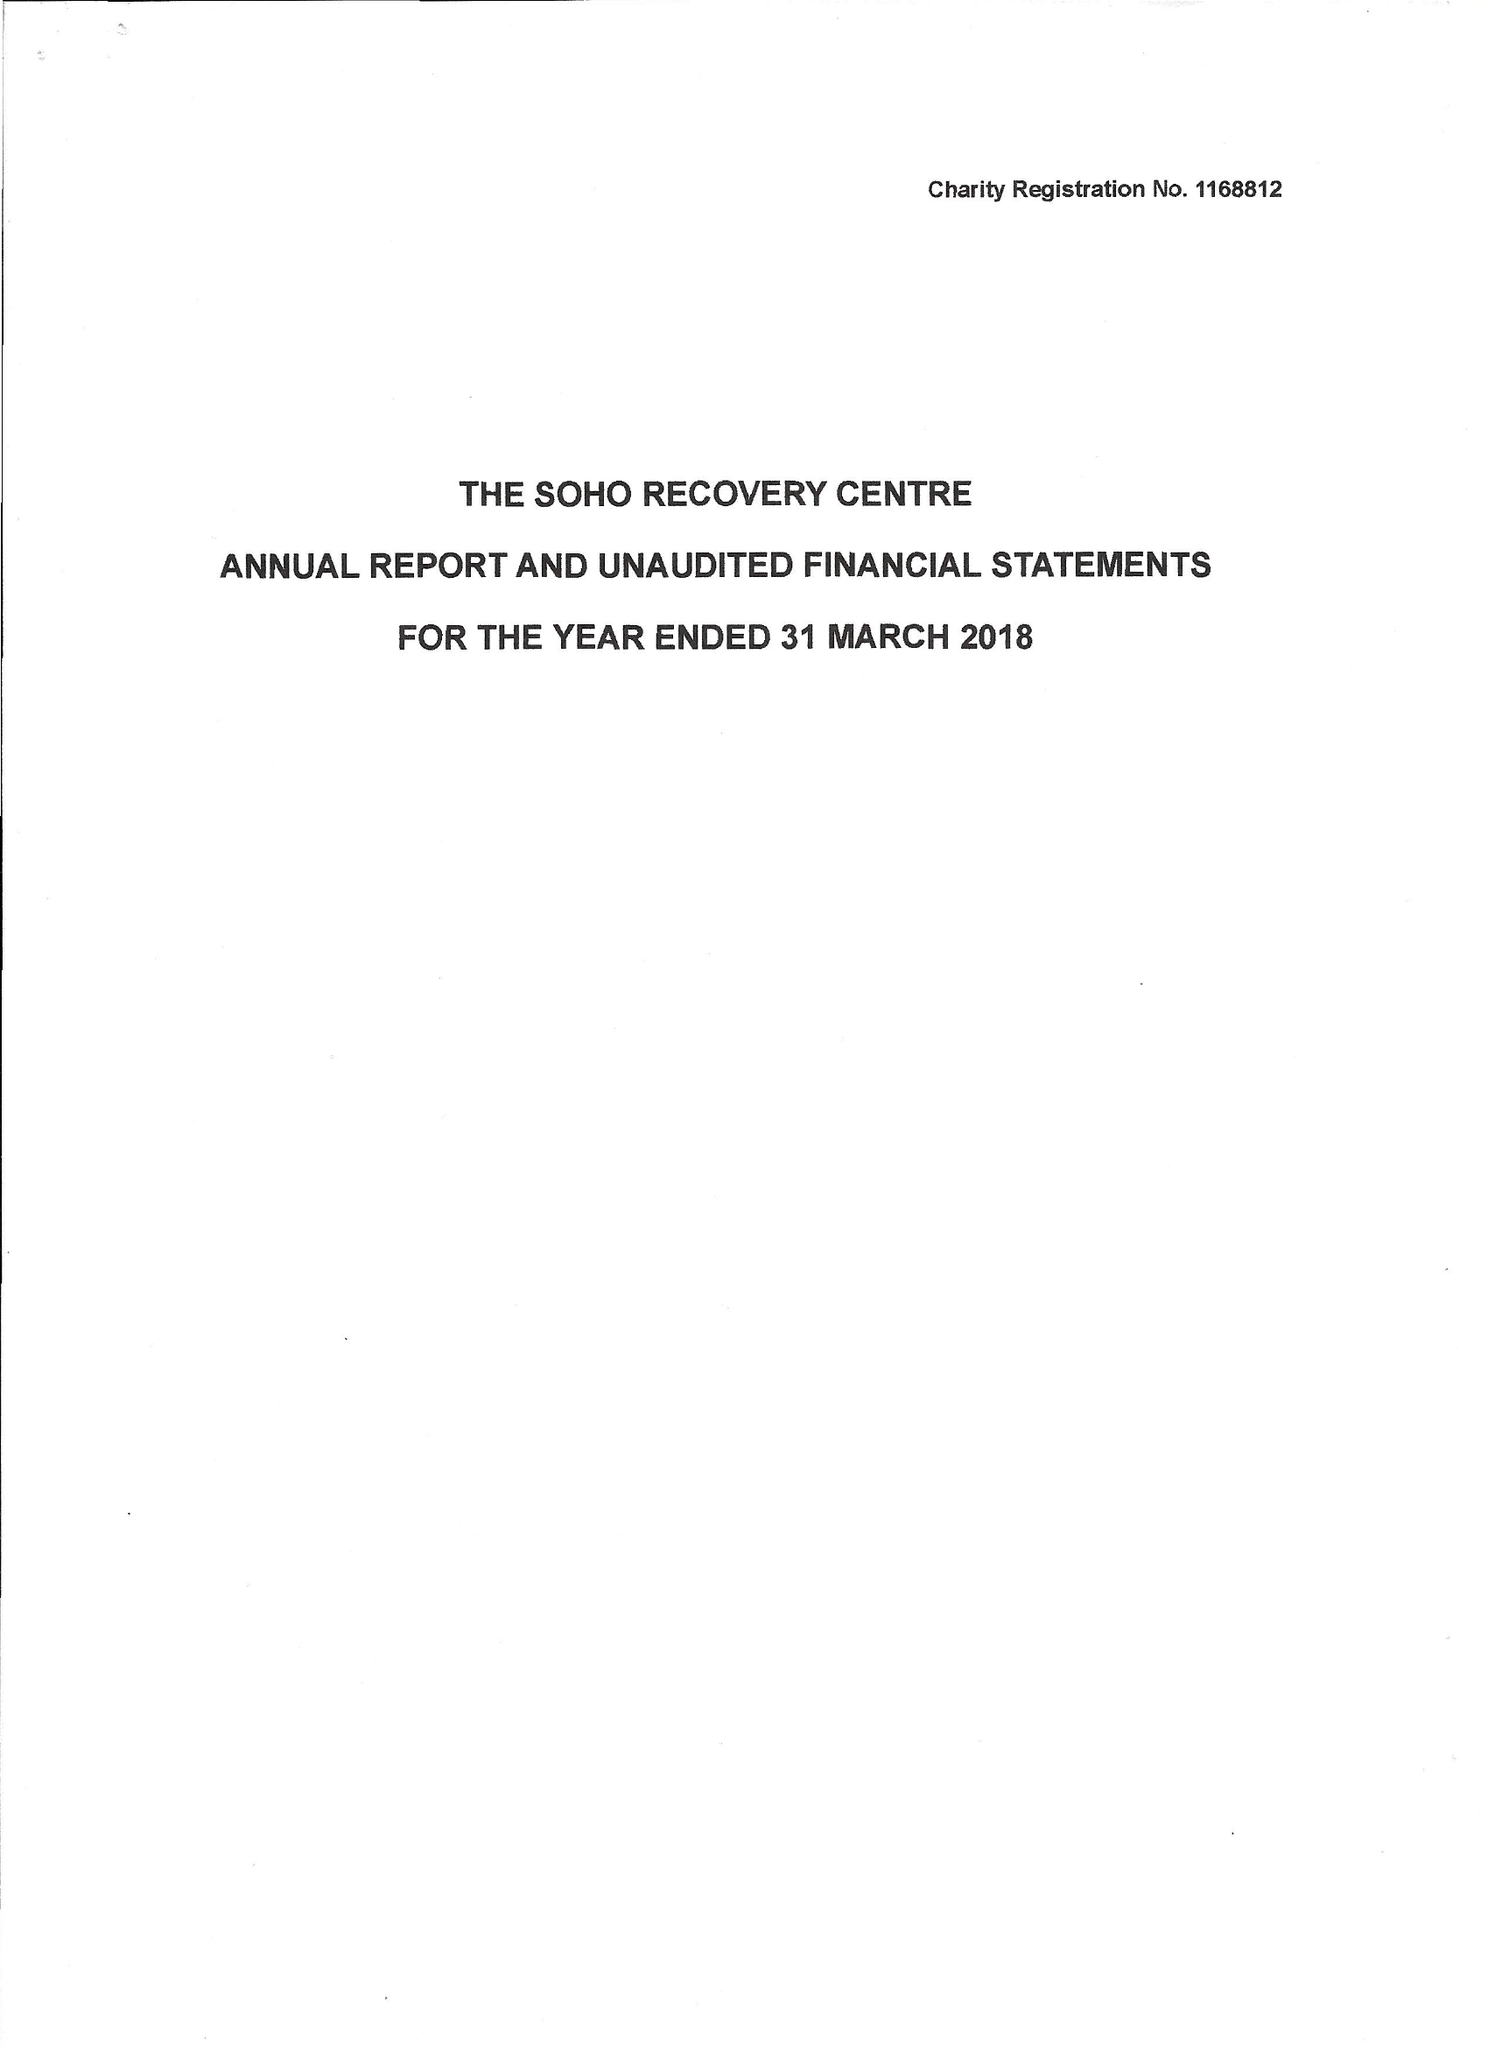What is the value for the spending_annually_in_british_pounds?
Answer the question using a single word or phrase. 48699.00 